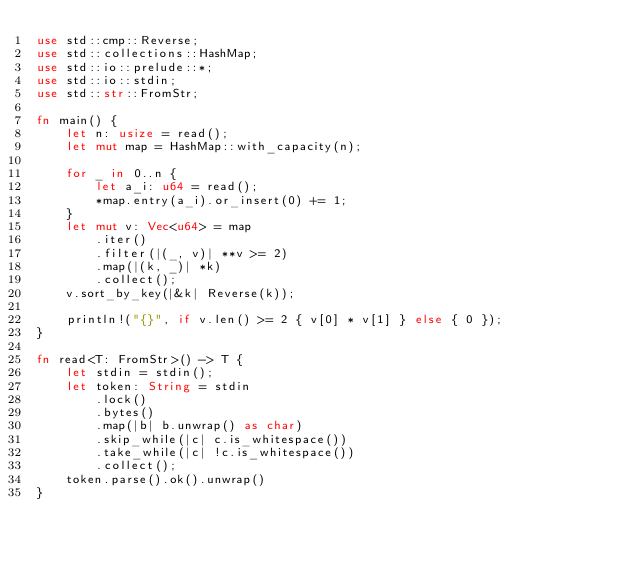<code> <loc_0><loc_0><loc_500><loc_500><_Rust_>use std::cmp::Reverse;
use std::collections::HashMap;
use std::io::prelude::*;
use std::io::stdin;
use std::str::FromStr;

fn main() {
    let n: usize = read();
    let mut map = HashMap::with_capacity(n);

    for _ in 0..n {
        let a_i: u64 = read();
        *map.entry(a_i).or_insert(0) += 1;
    }
    let mut v: Vec<u64> = map
        .iter()
        .filter(|(_, v)| **v >= 2)
        .map(|(k, _)| *k)
        .collect();
    v.sort_by_key(|&k| Reverse(k));

    println!("{}", if v.len() >= 2 { v[0] * v[1] } else { 0 });
}

fn read<T: FromStr>() -> T {
    let stdin = stdin();
    let token: String = stdin
        .lock()
        .bytes()
        .map(|b| b.unwrap() as char)
        .skip_while(|c| c.is_whitespace())
        .take_while(|c| !c.is_whitespace())
        .collect();
    token.parse().ok().unwrap()
}
</code> 